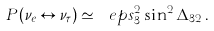Convert formula to latex. <formula><loc_0><loc_0><loc_500><loc_500>P ( \nu _ { e } \leftrightarrow \nu _ { \tau } ) \simeq \ e p s _ { 3 } ^ { 2 } \sin ^ { 2 } \Delta _ { 3 2 } \, .</formula> 